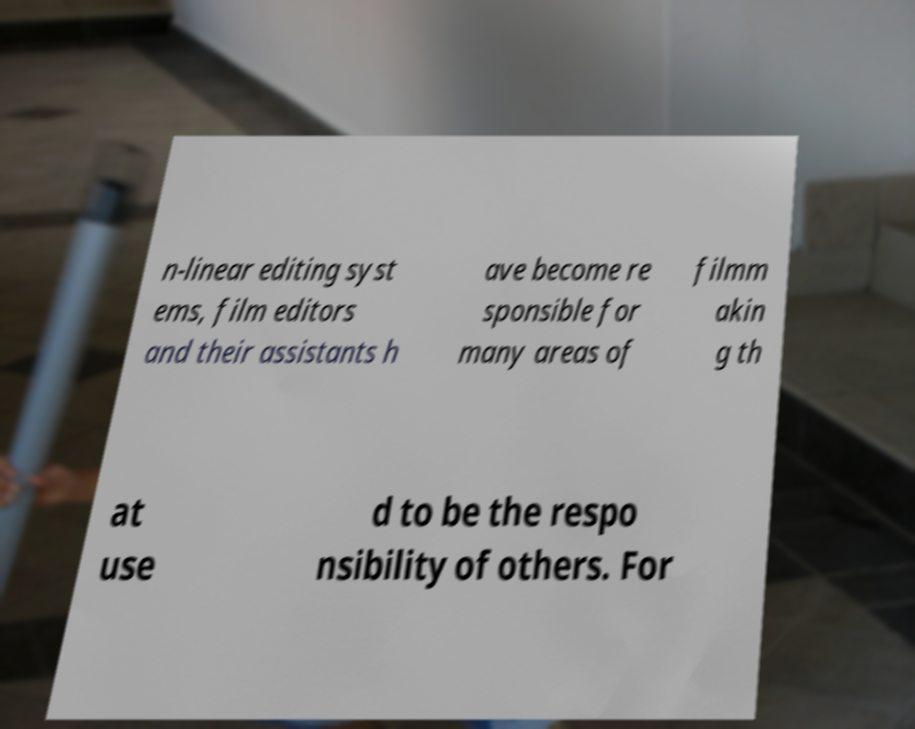I need the written content from this picture converted into text. Can you do that? n-linear editing syst ems, film editors and their assistants h ave become re sponsible for many areas of filmm akin g th at use d to be the respo nsibility of others. For 